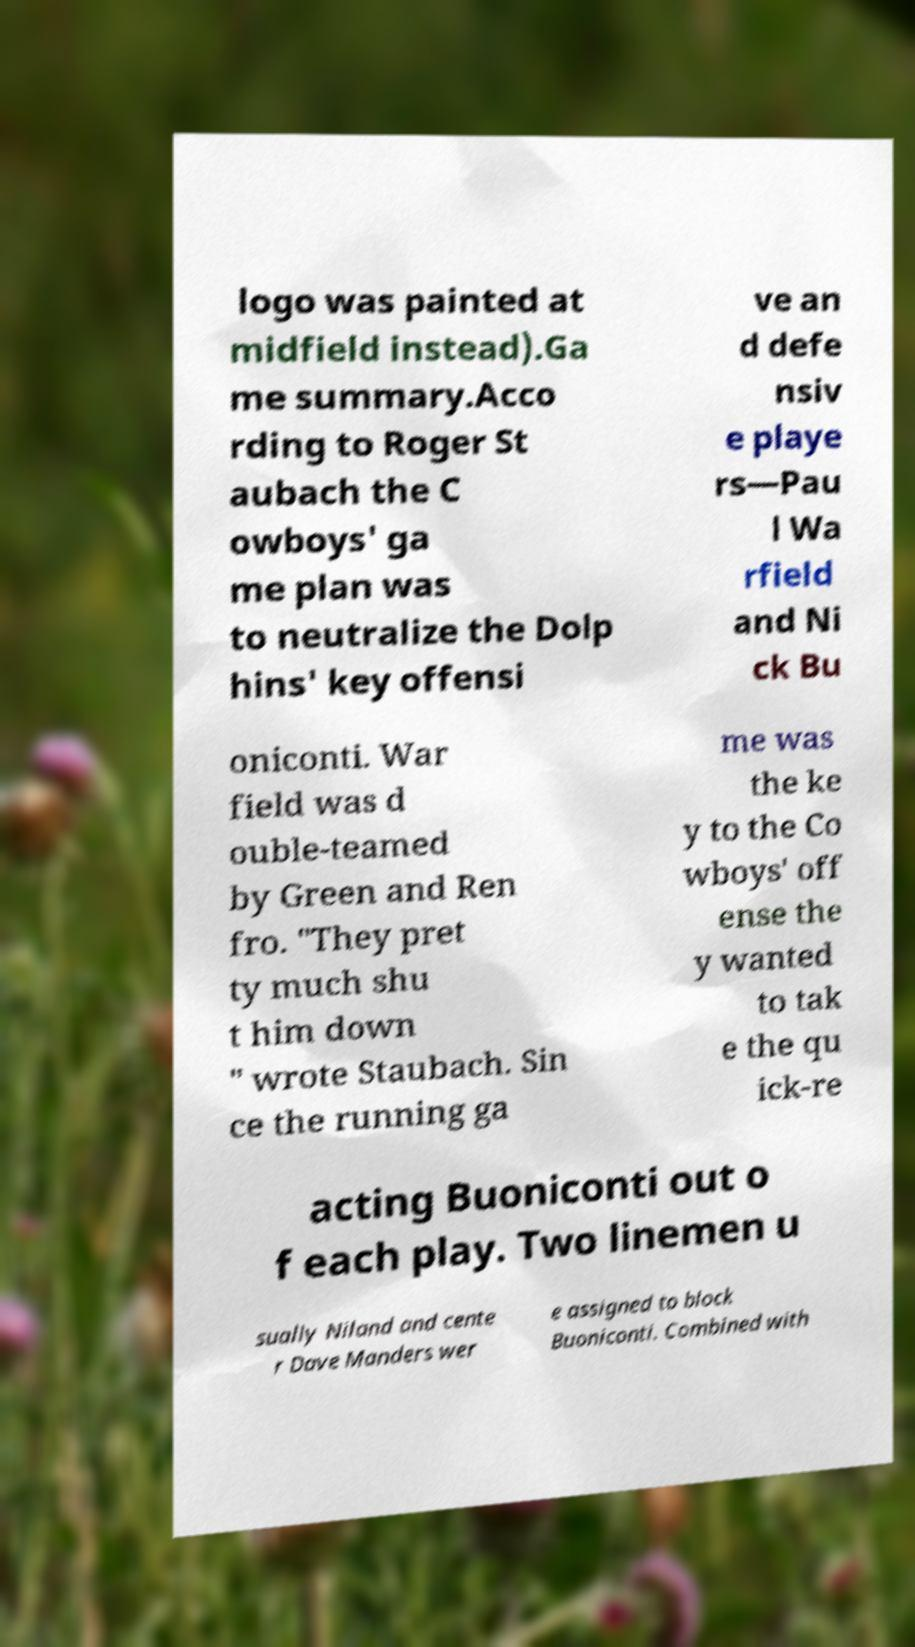Could you assist in decoding the text presented in this image and type it out clearly? logo was painted at midfield instead).Ga me summary.Acco rding to Roger St aubach the C owboys' ga me plan was to neutralize the Dolp hins' key offensi ve an d defe nsiv e playe rs—Pau l Wa rfield and Ni ck Bu oniconti. War field was d ouble-teamed by Green and Ren fro. "They pret ty much shu t him down " wrote Staubach. Sin ce the running ga me was the ke y to the Co wboys' off ense the y wanted to tak e the qu ick-re acting Buoniconti out o f each play. Two linemen u sually Niland and cente r Dave Manders wer e assigned to block Buoniconti. Combined with 